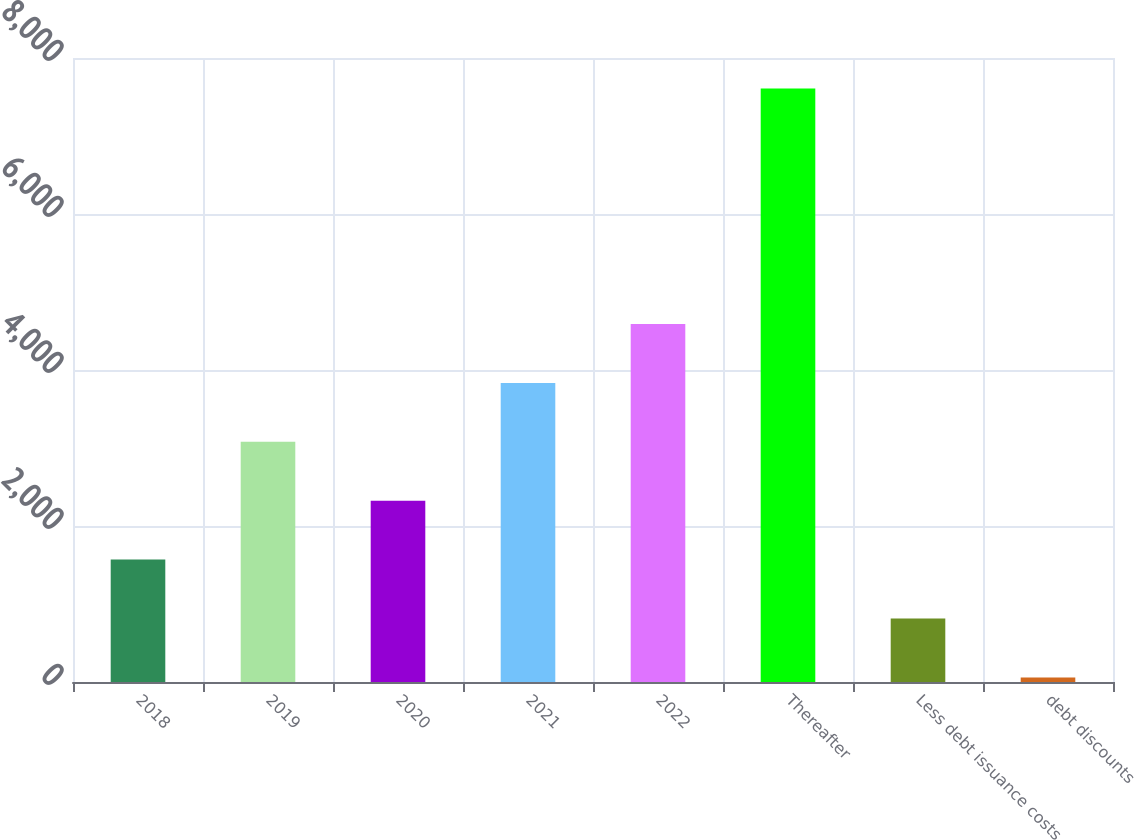Convert chart. <chart><loc_0><loc_0><loc_500><loc_500><bar_chart><fcel>2018<fcel>2019<fcel>2020<fcel>2021<fcel>2022<fcel>Thereafter<fcel>Less debt issuance costs<fcel>debt discounts<nl><fcel>1569<fcel>3079<fcel>2324<fcel>3834<fcel>4589<fcel>7609<fcel>814<fcel>59<nl></chart> 